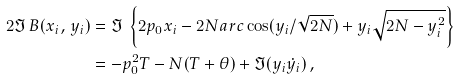Convert formula to latex. <formula><loc_0><loc_0><loc_500><loc_500>2 \Im \, B ( x _ { i } , \, y _ { i } ) & = \Im \, \left \{ 2 p _ { 0 } x _ { i } - 2 N a r c \cos ( y _ { i } / \sqrt { 2 N } ) + y _ { i } \sqrt { 2 N - y _ { i } ^ { 2 } } \right \} \\ & = - p _ { 0 } ^ { 2 } T - N ( T + \theta ) + \Im ( y _ { i } \dot { y } _ { i } ) \, ,</formula> 